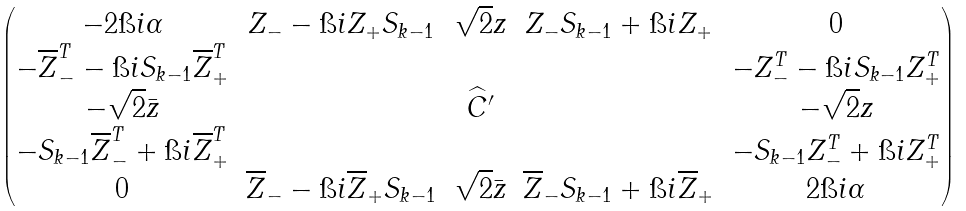<formula> <loc_0><loc_0><loc_500><loc_500>\begin{pmatrix} - 2 \i i \alpha & Z _ { - } - \i i Z _ { + } S _ { k - 1 } & \sqrt { 2 } z & Z _ { - } S _ { k - 1 } + \i i Z _ { + } & 0 \\ - \overline { Z } _ { - } ^ { T } - \i i S _ { k - 1 } \overline { Z } _ { + } ^ { T } & & & & - Z _ { - } ^ { T } - \i i S _ { k - 1 } Z _ { + } ^ { T } \\ - \sqrt { 2 } \bar { z } & & \widehat { C } ^ { \prime } & & - \sqrt { 2 } z \\ - S _ { k - 1 } \overline { Z } _ { - } ^ { T } + \i i \overline { Z } _ { + } ^ { T } & & & & - S _ { k - 1 } Z _ { - } ^ { T } + \i i Z _ { + } ^ { T } \\ 0 & \overline { Z } _ { - } - \i i \overline { Z } _ { + } S _ { k - 1 } & \sqrt { 2 } \bar { z } & \overline { Z } _ { - } S _ { k - 1 } + \i i \overline { Z } _ { + } & 2 \i i \alpha \end{pmatrix}</formula> 